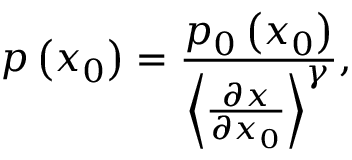<formula> <loc_0><loc_0><loc_500><loc_500>p \left ( x _ { 0 } \right ) = \frac { p _ { 0 } \left ( x _ { 0 } \right ) } { \left \langle \frac { \partial x } { \partial x _ { 0 } } \right \rangle ^ { \gamma } } ,</formula> 